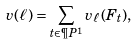<formula> <loc_0><loc_0><loc_500><loc_500>v ( \ell ) = \sum _ { t \in \P P ^ { 1 } } v _ { \ell } ( F _ { t } ) ,</formula> 